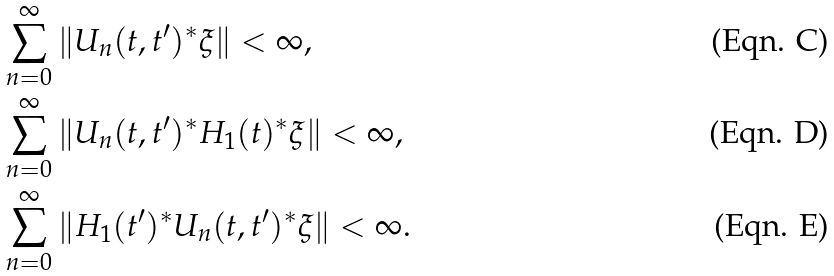Convert formula to latex. <formula><loc_0><loc_0><loc_500><loc_500>& \sum _ { n = 0 } ^ { \infty } \| U _ { n } ( t , t ^ { \prime } ) ^ { * } \xi \| < \infty , \\ & \sum _ { n = 0 } ^ { \infty } \| U _ { n } ( t , t ^ { \prime } ) ^ { * } H _ { 1 } ( t ) ^ { * } \xi \| < \infty , \\ & \sum _ { n = 0 } ^ { \infty } \| H _ { 1 } ( t ^ { \prime } ) ^ { * } U _ { n } ( t , t ^ { \prime } ) ^ { * } \xi \| < \infty .</formula> 